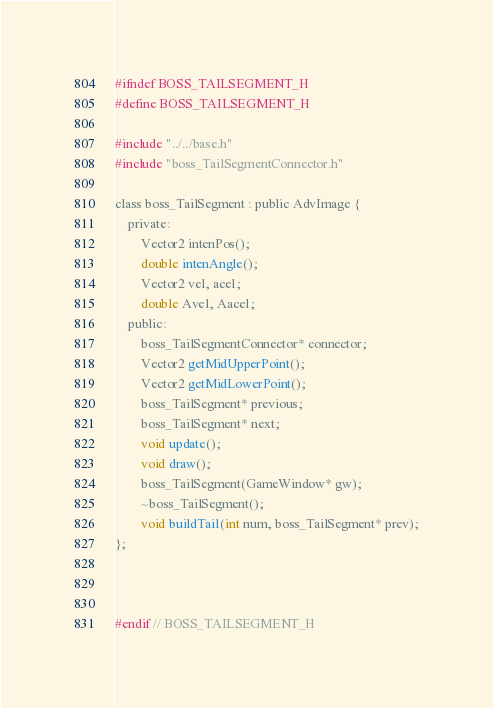<code> <loc_0><loc_0><loc_500><loc_500><_C_>#ifndef BOSS_TAILSEGMENT_H
#define BOSS_TAILSEGMENT_H

#include "../../base.h"
#include "boss_TailSegmentConnector.h"

class boss_TailSegment : public AdvImage {
	private:
		Vector2 intenPos();
		double intenAngle();
		Vector2 vel, acel;
		double Avel, Aacel;
	public:
		boss_TailSegmentConnector* connector;
		Vector2 getMidUpperPoint();
		Vector2 getMidLowerPoint();
		boss_TailSegment* previous;
		boss_TailSegment* next;
		void update();
		void draw();
		boss_TailSegment(GameWindow* gw);
		~boss_TailSegment();
		void buildTail(int num, boss_TailSegment* prev);
};



#endif // BOSS_TAILSEGMENT_H
</code> 